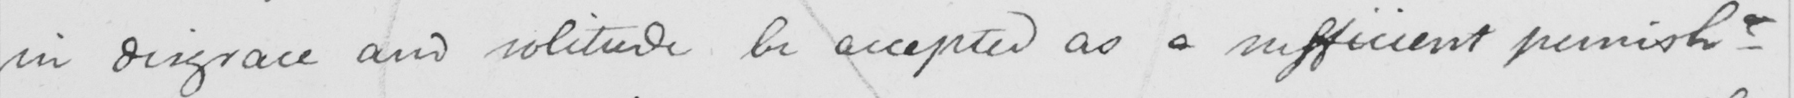What is written in this line of handwriting? in disgrace and solitude be accepted as a sufficient punish- 